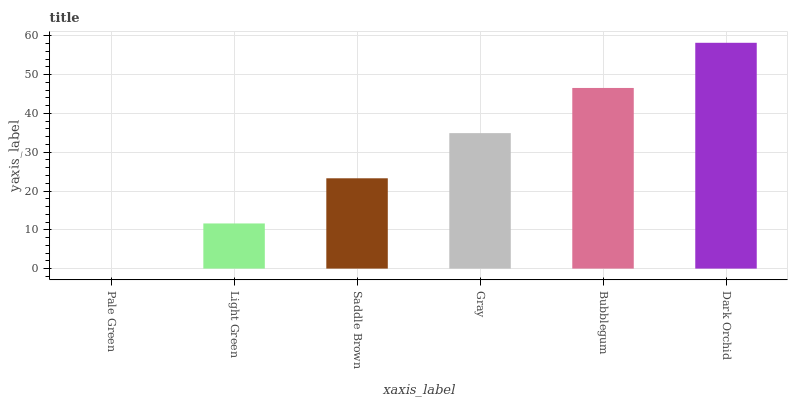Is Pale Green the minimum?
Answer yes or no. Yes. Is Dark Orchid the maximum?
Answer yes or no. Yes. Is Light Green the minimum?
Answer yes or no. No. Is Light Green the maximum?
Answer yes or no. No. Is Light Green greater than Pale Green?
Answer yes or no. Yes. Is Pale Green less than Light Green?
Answer yes or no. Yes. Is Pale Green greater than Light Green?
Answer yes or no. No. Is Light Green less than Pale Green?
Answer yes or no. No. Is Gray the high median?
Answer yes or no. Yes. Is Saddle Brown the low median?
Answer yes or no. Yes. Is Pale Green the high median?
Answer yes or no. No. Is Bubblegum the low median?
Answer yes or no. No. 